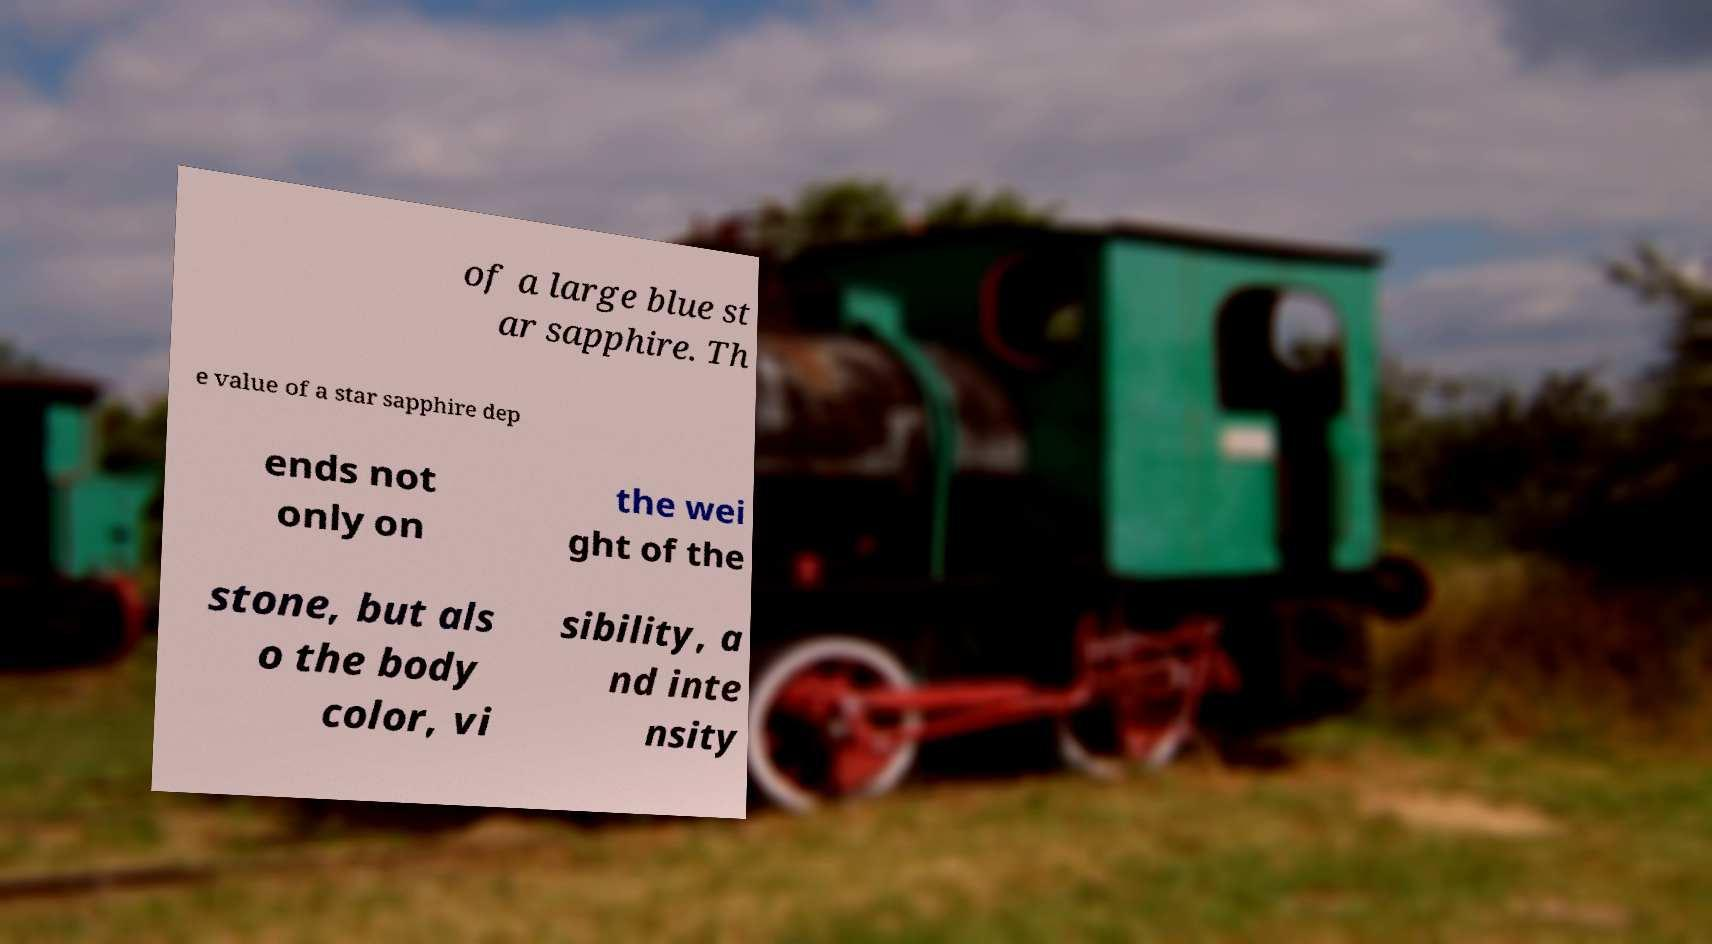Please identify and transcribe the text found in this image. of a large blue st ar sapphire. Th e value of a star sapphire dep ends not only on the wei ght of the stone, but als o the body color, vi sibility, a nd inte nsity 